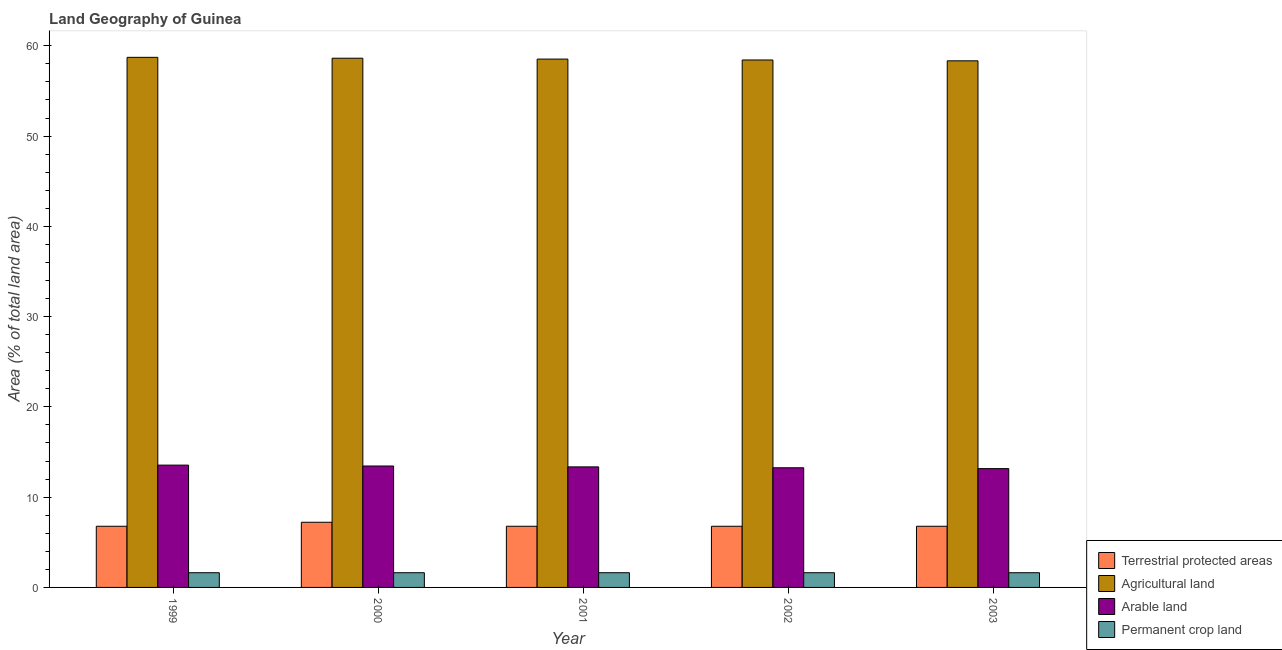How many different coloured bars are there?
Offer a very short reply. 4. How many groups of bars are there?
Your answer should be compact. 5. Are the number of bars per tick equal to the number of legend labels?
Your response must be concise. Yes. What is the percentage of land under terrestrial protection in 2002?
Keep it short and to the point. 6.78. Across all years, what is the maximum percentage of area under agricultural land?
Provide a short and direct response. 58.72. Across all years, what is the minimum percentage of area under arable land?
Your answer should be very brief. 13.16. What is the total percentage of land under terrestrial protection in the graph?
Keep it short and to the point. 34.32. What is the difference between the percentage of area under arable land in 2001 and that in 2002?
Ensure brevity in your answer.  0.1. What is the difference between the percentage of area under arable land in 2003 and the percentage of area under permanent crop land in 2002?
Your response must be concise. -0.09. What is the average percentage of land under terrestrial protection per year?
Offer a very short reply. 6.86. In the year 2000, what is the difference between the percentage of land under terrestrial protection and percentage of area under permanent crop land?
Offer a terse response. 0. In how many years, is the percentage of area under permanent crop land greater than 46 %?
Offer a terse response. 0. What is the ratio of the percentage of land under terrestrial protection in 1999 to that in 2002?
Provide a succinct answer. 1. Is the percentage of area under agricultural land in 1999 less than that in 2003?
Keep it short and to the point. No. Is the difference between the percentage of area under agricultural land in 1999 and 2002 greater than the difference between the percentage of area under arable land in 1999 and 2002?
Offer a very short reply. No. What is the difference between the highest and the second highest percentage of land under terrestrial protection?
Your answer should be very brief. 0.44. In how many years, is the percentage of area under agricultural land greater than the average percentage of area under agricultural land taken over all years?
Your answer should be very brief. 2. Is it the case that in every year, the sum of the percentage of area under arable land and percentage of area under permanent crop land is greater than the sum of percentage of area under agricultural land and percentage of land under terrestrial protection?
Ensure brevity in your answer.  No. What does the 1st bar from the left in 1999 represents?
Provide a short and direct response. Terrestrial protected areas. What does the 1st bar from the right in 2003 represents?
Ensure brevity in your answer.  Permanent crop land. Is it the case that in every year, the sum of the percentage of land under terrestrial protection and percentage of area under agricultural land is greater than the percentage of area under arable land?
Your answer should be compact. Yes. How many bars are there?
Keep it short and to the point. 20. What is the difference between two consecutive major ticks on the Y-axis?
Your response must be concise. 10. Are the values on the major ticks of Y-axis written in scientific E-notation?
Offer a very short reply. No. Does the graph contain any zero values?
Offer a terse response. No. Where does the legend appear in the graph?
Give a very brief answer. Bottom right. How many legend labels are there?
Ensure brevity in your answer.  4. How are the legend labels stacked?
Ensure brevity in your answer.  Vertical. What is the title of the graph?
Offer a very short reply. Land Geography of Guinea. Does "Secondary schools" appear as one of the legend labels in the graph?
Give a very brief answer. No. What is the label or title of the Y-axis?
Your answer should be compact. Area (% of total land area). What is the Area (% of total land area) in Terrestrial protected areas in 1999?
Keep it short and to the point. 6.78. What is the Area (% of total land area) of Agricultural land in 1999?
Your answer should be very brief. 58.72. What is the Area (% of total land area) of Arable land in 1999?
Your answer should be very brief. 13.55. What is the Area (% of total land area) of Permanent crop land in 1999?
Provide a short and direct response. 1.63. What is the Area (% of total land area) of Terrestrial protected areas in 2000?
Provide a succinct answer. 7.22. What is the Area (% of total land area) in Agricultural land in 2000?
Keep it short and to the point. 58.62. What is the Area (% of total land area) of Arable land in 2000?
Your response must be concise. 13.45. What is the Area (% of total land area) in Permanent crop land in 2000?
Make the answer very short. 1.63. What is the Area (% of total land area) in Terrestrial protected areas in 2001?
Your answer should be very brief. 6.78. What is the Area (% of total land area) in Agricultural land in 2001?
Your answer should be compact. 58.53. What is the Area (% of total land area) in Arable land in 2001?
Provide a succinct answer. 13.35. What is the Area (% of total land area) in Permanent crop land in 2001?
Keep it short and to the point. 1.63. What is the Area (% of total land area) of Terrestrial protected areas in 2002?
Offer a terse response. 6.78. What is the Area (% of total land area) of Agricultural land in 2002?
Your answer should be compact. 58.43. What is the Area (% of total land area) in Arable land in 2002?
Provide a short and direct response. 13.25. What is the Area (% of total land area) of Permanent crop land in 2002?
Offer a very short reply. 1.63. What is the Area (% of total land area) of Terrestrial protected areas in 2003?
Your answer should be compact. 6.78. What is the Area (% of total land area) in Agricultural land in 2003?
Provide a short and direct response. 58.33. What is the Area (% of total land area) in Arable land in 2003?
Your response must be concise. 13.16. What is the Area (% of total land area) of Permanent crop land in 2003?
Offer a terse response. 1.63. Across all years, what is the maximum Area (% of total land area) of Terrestrial protected areas?
Provide a succinct answer. 7.22. Across all years, what is the maximum Area (% of total land area) of Agricultural land?
Your answer should be very brief. 58.72. Across all years, what is the maximum Area (% of total land area) in Arable land?
Provide a short and direct response. 13.55. Across all years, what is the maximum Area (% of total land area) of Permanent crop land?
Provide a short and direct response. 1.63. Across all years, what is the minimum Area (% of total land area) of Terrestrial protected areas?
Your answer should be compact. 6.78. Across all years, what is the minimum Area (% of total land area) in Agricultural land?
Offer a very short reply. 58.33. Across all years, what is the minimum Area (% of total land area) in Arable land?
Ensure brevity in your answer.  13.16. Across all years, what is the minimum Area (% of total land area) in Permanent crop land?
Offer a very short reply. 1.63. What is the total Area (% of total land area) in Terrestrial protected areas in the graph?
Your answer should be compact. 34.32. What is the total Area (% of total land area) in Agricultural land in the graph?
Make the answer very short. 292.63. What is the total Area (% of total land area) in Arable land in the graph?
Ensure brevity in your answer.  66.77. What is the total Area (% of total land area) of Permanent crop land in the graph?
Your answer should be very brief. 8.14. What is the difference between the Area (% of total land area) in Terrestrial protected areas in 1999 and that in 2000?
Your answer should be compact. -0.44. What is the difference between the Area (% of total land area) in Agricultural land in 1999 and that in 2000?
Ensure brevity in your answer.  0.1. What is the difference between the Area (% of total land area) in Arable land in 1999 and that in 2000?
Offer a terse response. 0.1. What is the difference between the Area (% of total land area) of Permanent crop land in 1999 and that in 2000?
Make the answer very short. 0. What is the difference between the Area (% of total land area) in Agricultural land in 1999 and that in 2001?
Give a very brief answer. 0.2. What is the difference between the Area (% of total land area) in Arable land in 1999 and that in 2001?
Your answer should be compact. 0.2. What is the difference between the Area (% of total land area) of Permanent crop land in 1999 and that in 2001?
Your response must be concise. 0. What is the difference between the Area (% of total land area) in Agricultural land in 1999 and that in 2002?
Give a very brief answer. 0.29. What is the difference between the Area (% of total land area) of Arable land in 1999 and that in 2002?
Offer a very short reply. 0.29. What is the difference between the Area (% of total land area) in Terrestrial protected areas in 1999 and that in 2003?
Provide a short and direct response. -0. What is the difference between the Area (% of total land area) of Agricultural land in 1999 and that in 2003?
Ensure brevity in your answer.  0.39. What is the difference between the Area (% of total land area) in Arable land in 1999 and that in 2003?
Offer a terse response. 0.39. What is the difference between the Area (% of total land area) of Terrestrial protected areas in 2000 and that in 2001?
Make the answer very short. 0.44. What is the difference between the Area (% of total land area) of Agricultural land in 2000 and that in 2001?
Give a very brief answer. 0.1. What is the difference between the Area (% of total land area) in Arable land in 2000 and that in 2001?
Make the answer very short. 0.1. What is the difference between the Area (% of total land area) of Permanent crop land in 2000 and that in 2001?
Offer a very short reply. 0. What is the difference between the Area (% of total land area) in Terrestrial protected areas in 2000 and that in 2002?
Offer a very short reply. 0.44. What is the difference between the Area (% of total land area) of Agricultural land in 2000 and that in 2002?
Offer a very short reply. 0.2. What is the difference between the Area (% of total land area) of Arable land in 2000 and that in 2002?
Provide a short and direct response. 0.2. What is the difference between the Area (% of total land area) in Permanent crop land in 2000 and that in 2002?
Make the answer very short. 0. What is the difference between the Area (% of total land area) in Terrestrial protected areas in 2000 and that in 2003?
Your answer should be compact. 0.44. What is the difference between the Area (% of total land area) of Agricultural land in 2000 and that in 2003?
Offer a terse response. 0.29. What is the difference between the Area (% of total land area) of Arable land in 2000 and that in 2003?
Your response must be concise. 0.29. What is the difference between the Area (% of total land area) of Permanent crop land in 2000 and that in 2003?
Offer a very short reply. 0. What is the difference between the Area (% of total land area) in Terrestrial protected areas in 2001 and that in 2002?
Your response must be concise. 0. What is the difference between the Area (% of total land area) of Agricultural land in 2001 and that in 2002?
Ensure brevity in your answer.  0.1. What is the difference between the Area (% of total land area) in Arable land in 2001 and that in 2002?
Offer a terse response. 0.1. What is the difference between the Area (% of total land area) of Terrestrial protected areas in 2001 and that in 2003?
Offer a very short reply. -0. What is the difference between the Area (% of total land area) in Agricultural land in 2001 and that in 2003?
Keep it short and to the point. 0.19. What is the difference between the Area (% of total land area) in Arable land in 2001 and that in 2003?
Your answer should be compact. 0.19. What is the difference between the Area (% of total land area) in Terrestrial protected areas in 2002 and that in 2003?
Keep it short and to the point. -0. What is the difference between the Area (% of total land area) of Agricultural land in 2002 and that in 2003?
Ensure brevity in your answer.  0.09. What is the difference between the Area (% of total land area) of Arable land in 2002 and that in 2003?
Make the answer very short. 0.09. What is the difference between the Area (% of total land area) in Permanent crop land in 2002 and that in 2003?
Ensure brevity in your answer.  0. What is the difference between the Area (% of total land area) in Terrestrial protected areas in 1999 and the Area (% of total land area) in Agricultural land in 2000?
Give a very brief answer. -51.85. What is the difference between the Area (% of total land area) in Terrestrial protected areas in 1999 and the Area (% of total land area) in Arable land in 2000?
Give a very brief answer. -6.68. What is the difference between the Area (% of total land area) of Terrestrial protected areas in 1999 and the Area (% of total land area) of Permanent crop land in 2000?
Keep it short and to the point. 5.15. What is the difference between the Area (% of total land area) in Agricultural land in 1999 and the Area (% of total land area) in Arable land in 2000?
Keep it short and to the point. 45.27. What is the difference between the Area (% of total land area) of Agricultural land in 1999 and the Area (% of total land area) of Permanent crop land in 2000?
Ensure brevity in your answer.  57.09. What is the difference between the Area (% of total land area) of Arable land in 1999 and the Area (% of total land area) of Permanent crop land in 2000?
Provide a succinct answer. 11.92. What is the difference between the Area (% of total land area) of Terrestrial protected areas in 1999 and the Area (% of total land area) of Agricultural land in 2001?
Make the answer very short. -51.75. What is the difference between the Area (% of total land area) of Terrestrial protected areas in 1999 and the Area (% of total land area) of Arable land in 2001?
Give a very brief answer. -6.58. What is the difference between the Area (% of total land area) of Terrestrial protected areas in 1999 and the Area (% of total land area) of Permanent crop land in 2001?
Keep it short and to the point. 5.15. What is the difference between the Area (% of total land area) of Agricultural land in 1999 and the Area (% of total land area) of Arable land in 2001?
Keep it short and to the point. 45.37. What is the difference between the Area (% of total land area) in Agricultural land in 1999 and the Area (% of total land area) in Permanent crop land in 2001?
Offer a very short reply. 57.09. What is the difference between the Area (% of total land area) in Arable land in 1999 and the Area (% of total land area) in Permanent crop land in 2001?
Give a very brief answer. 11.92. What is the difference between the Area (% of total land area) of Terrestrial protected areas in 1999 and the Area (% of total land area) of Agricultural land in 2002?
Your answer should be very brief. -51.65. What is the difference between the Area (% of total land area) of Terrestrial protected areas in 1999 and the Area (% of total land area) of Arable land in 2002?
Keep it short and to the point. -6.48. What is the difference between the Area (% of total land area) in Terrestrial protected areas in 1999 and the Area (% of total land area) in Permanent crop land in 2002?
Keep it short and to the point. 5.15. What is the difference between the Area (% of total land area) in Agricultural land in 1999 and the Area (% of total land area) in Arable land in 2002?
Give a very brief answer. 45.47. What is the difference between the Area (% of total land area) of Agricultural land in 1999 and the Area (% of total land area) of Permanent crop land in 2002?
Your response must be concise. 57.09. What is the difference between the Area (% of total land area) in Arable land in 1999 and the Area (% of total land area) in Permanent crop land in 2002?
Your answer should be compact. 11.92. What is the difference between the Area (% of total land area) of Terrestrial protected areas in 1999 and the Area (% of total land area) of Agricultural land in 2003?
Make the answer very short. -51.56. What is the difference between the Area (% of total land area) of Terrestrial protected areas in 1999 and the Area (% of total land area) of Arable land in 2003?
Ensure brevity in your answer.  -6.39. What is the difference between the Area (% of total land area) in Terrestrial protected areas in 1999 and the Area (% of total land area) in Permanent crop land in 2003?
Offer a very short reply. 5.15. What is the difference between the Area (% of total land area) of Agricultural land in 1999 and the Area (% of total land area) of Arable land in 2003?
Provide a succinct answer. 45.56. What is the difference between the Area (% of total land area) in Agricultural land in 1999 and the Area (% of total land area) in Permanent crop land in 2003?
Provide a succinct answer. 57.09. What is the difference between the Area (% of total land area) in Arable land in 1999 and the Area (% of total land area) in Permanent crop land in 2003?
Offer a very short reply. 11.92. What is the difference between the Area (% of total land area) in Terrestrial protected areas in 2000 and the Area (% of total land area) in Agricultural land in 2001?
Make the answer very short. -51.31. What is the difference between the Area (% of total land area) in Terrestrial protected areas in 2000 and the Area (% of total land area) in Arable land in 2001?
Offer a terse response. -6.13. What is the difference between the Area (% of total land area) of Terrestrial protected areas in 2000 and the Area (% of total land area) of Permanent crop land in 2001?
Provide a succinct answer. 5.59. What is the difference between the Area (% of total land area) in Agricultural land in 2000 and the Area (% of total land area) in Arable land in 2001?
Give a very brief answer. 45.27. What is the difference between the Area (% of total land area) of Agricultural land in 2000 and the Area (% of total land area) of Permanent crop land in 2001?
Provide a succinct answer. 57. What is the difference between the Area (% of total land area) in Arable land in 2000 and the Area (% of total land area) in Permanent crop land in 2001?
Keep it short and to the point. 11.82. What is the difference between the Area (% of total land area) in Terrestrial protected areas in 2000 and the Area (% of total land area) in Agricultural land in 2002?
Provide a short and direct response. -51.21. What is the difference between the Area (% of total land area) of Terrestrial protected areas in 2000 and the Area (% of total land area) of Arable land in 2002?
Keep it short and to the point. -6.04. What is the difference between the Area (% of total land area) in Terrestrial protected areas in 2000 and the Area (% of total land area) in Permanent crop land in 2002?
Provide a succinct answer. 5.59. What is the difference between the Area (% of total land area) of Agricultural land in 2000 and the Area (% of total land area) of Arable land in 2002?
Make the answer very short. 45.37. What is the difference between the Area (% of total land area) in Agricultural land in 2000 and the Area (% of total land area) in Permanent crop land in 2002?
Offer a terse response. 57. What is the difference between the Area (% of total land area) of Arable land in 2000 and the Area (% of total land area) of Permanent crop land in 2002?
Offer a terse response. 11.82. What is the difference between the Area (% of total land area) in Terrestrial protected areas in 2000 and the Area (% of total land area) in Agricultural land in 2003?
Ensure brevity in your answer.  -51.12. What is the difference between the Area (% of total land area) of Terrestrial protected areas in 2000 and the Area (% of total land area) of Arable land in 2003?
Your answer should be very brief. -5.94. What is the difference between the Area (% of total land area) of Terrestrial protected areas in 2000 and the Area (% of total land area) of Permanent crop land in 2003?
Your answer should be very brief. 5.59. What is the difference between the Area (% of total land area) in Agricultural land in 2000 and the Area (% of total land area) in Arable land in 2003?
Your answer should be very brief. 45.46. What is the difference between the Area (% of total land area) in Agricultural land in 2000 and the Area (% of total land area) in Permanent crop land in 2003?
Give a very brief answer. 57. What is the difference between the Area (% of total land area) in Arable land in 2000 and the Area (% of total land area) in Permanent crop land in 2003?
Ensure brevity in your answer.  11.82. What is the difference between the Area (% of total land area) of Terrestrial protected areas in 2001 and the Area (% of total land area) of Agricultural land in 2002?
Your answer should be compact. -51.65. What is the difference between the Area (% of total land area) of Terrestrial protected areas in 2001 and the Area (% of total land area) of Arable land in 2002?
Keep it short and to the point. -6.48. What is the difference between the Area (% of total land area) in Terrestrial protected areas in 2001 and the Area (% of total land area) in Permanent crop land in 2002?
Offer a very short reply. 5.15. What is the difference between the Area (% of total land area) in Agricultural land in 2001 and the Area (% of total land area) in Arable land in 2002?
Make the answer very short. 45.27. What is the difference between the Area (% of total land area) in Agricultural land in 2001 and the Area (% of total land area) in Permanent crop land in 2002?
Your answer should be very brief. 56.9. What is the difference between the Area (% of total land area) in Arable land in 2001 and the Area (% of total land area) in Permanent crop land in 2002?
Make the answer very short. 11.72. What is the difference between the Area (% of total land area) of Terrestrial protected areas in 2001 and the Area (% of total land area) of Agricultural land in 2003?
Give a very brief answer. -51.56. What is the difference between the Area (% of total land area) of Terrestrial protected areas in 2001 and the Area (% of total land area) of Arable land in 2003?
Keep it short and to the point. -6.39. What is the difference between the Area (% of total land area) of Terrestrial protected areas in 2001 and the Area (% of total land area) of Permanent crop land in 2003?
Offer a very short reply. 5.15. What is the difference between the Area (% of total land area) of Agricultural land in 2001 and the Area (% of total land area) of Arable land in 2003?
Offer a terse response. 45.36. What is the difference between the Area (% of total land area) in Agricultural land in 2001 and the Area (% of total land area) in Permanent crop land in 2003?
Offer a terse response. 56.9. What is the difference between the Area (% of total land area) in Arable land in 2001 and the Area (% of total land area) in Permanent crop land in 2003?
Provide a succinct answer. 11.72. What is the difference between the Area (% of total land area) in Terrestrial protected areas in 2002 and the Area (% of total land area) in Agricultural land in 2003?
Your answer should be compact. -51.56. What is the difference between the Area (% of total land area) in Terrestrial protected areas in 2002 and the Area (% of total land area) in Arable land in 2003?
Offer a very short reply. -6.39. What is the difference between the Area (% of total land area) of Terrestrial protected areas in 2002 and the Area (% of total land area) of Permanent crop land in 2003?
Provide a short and direct response. 5.15. What is the difference between the Area (% of total land area) of Agricultural land in 2002 and the Area (% of total land area) of Arable land in 2003?
Your response must be concise. 45.27. What is the difference between the Area (% of total land area) of Agricultural land in 2002 and the Area (% of total land area) of Permanent crop land in 2003?
Your answer should be very brief. 56.8. What is the difference between the Area (% of total land area) in Arable land in 2002 and the Area (% of total land area) in Permanent crop land in 2003?
Keep it short and to the point. 11.63. What is the average Area (% of total land area) in Terrestrial protected areas per year?
Offer a very short reply. 6.86. What is the average Area (% of total land area) of Agricultural land per year?
Make the answer very short. 58.53. What is the average Area (% of total land area) in Arable land per year?
Your answer should be very brief. 13.35. What is the average Area (% of total land area) in Permanent crop land per year?
Offer a terse response. 1.63. In the year 1999, what is the difference between the Area (% of total land area) in Terrestrial protected areas and Area (% of total land area) in Agricultural land?
Your answer should be compact. -51.95. In the year 1999, what is the difference between the Area (% of total land area) in Terrestrial protected areas and Area (% of total land area) in Arable land?
Give a very brief answer. -6.77. In the year 1999, what is the difference between the Area (% of total land area) in Terrestrial protected areas and Area (% of total land area) in Permanent crop land?
Your answer should be very brief. 5.15. In the year 1999, what is the difference between the Area (% of total land area) of Agricultural land and Area (% of total land area) of Arable land?
Offer a terse response. 45.17. In the year 1999, what is the difference between the Area (% of total land area) in Agricultural land and Area (% of total land area) in Permanent crop land?
Make the answer very short. 57.09. In the year 1999, what is the difference between the Area (% of total land area) in Arable land and Area (% of total land area) in Permanent crop land?
Give a very brief answer. 11.92. In the year 2000, what is the difference between the Area (% of total land area) in Terrestrial protected areas and Area (% of total land area) in Agricultural land?
Your answer should be very brief. -51.4. In the year 2000, what is the difference between the Area (% of total land area) in Terrestrial protected areas and Area (% of total land area) in Arable land?
Offer a very short reply. -6.23. In the year 2000, what is the difference between the Area (% of total land area) of Terrestrial protected areas and Area (% of total land area) of Permanent crop land?
Make the answer very short. 5.59. In the year 2000, what is the difference between the Area (% of total land area) in Agricultural land and Area (% of total land area) in Arable land?
Give a very brief answer. 45.17. In the year 2000, what is the difference between the Area (% of total land area) of Agricultural land and Area (% of total land area) of Permanent crop land?
Give a very brief answer. 57. In the year 2000, what is the difference between the Area (% of total land area) of Arable land and Area (% of total land area) of Permanent crop land?
Keep it short and to the point. 11.82. In the year 2001, what is the difference between the Area (% of total land area) in Terrestrial protected areas and Area (% of total land area) in Agricultural land?
Give a very brief answer. -51.75. In the year 2001, what is the difference between the Area (% of total land area) in Terrestrial protected areas and Area (% of total land area) in Arable land?
Provide a succinct answer. -6.58. In the year 2001, what is the difference between the Area (% of total land area) in Terrestrial protected areas and Area (% of total land area) in Permanent crop land?
Make the answer very short. 5.15. In the year 2001, what is the difference between the Area (% of total land area) in Agricultural land and Area (% of total land area) in Arable land?
Provide a short and direct response. 45.17. In the year 2001, what is the difference between the Area (% of total land area) of Agricultural land and Area (% of total land area) of Permanent crop land?
Offer a terse response. 56.9. In the year 2001, what is the difference between the Area (% of total land area) of Arable land and Area (% of total land area) of Permanent crop land?
Provide a short and direct response. 11.72. In the year 2002, what is the difference between the Area (% of total land area) of Terrestrial protected areas and Area (% of total land area) of Agricultural land?
Your answer should be very brief. -51.65. In the year 2002, what is the difference between the Area (% of total land area) of Terrestrial protected areas and Area (% of total land area) of Arable land?
Provide a short and direct response. -6.48. In the year 2002, what is the difference between the Area (% of total land area) in Terrestrial protected areas and Area (% of total land area) in Permanent crop land?
Give a very brief answer. 5.15. In the year 2002, what is the difference between the Area (% of total land area) of Agricultural land and Area (% of total land area) of Arable land?
Keep it short and to the point. 45.17. In the year 2002, what is the difference between the Area (% of total land area) of Agricultural land and Area (% of total land area) of Permanent crop land?
Keep it short and to the point. 56.8. In the year 2002, what is the difference between the Area (% of total land area) in Arable land and Area (% of total land area) in Permanent crop land?
Your response must be concise. 11.63. In the year 2003, what is the difference between the Area (% of total land area) in Terrestrial protected areas and Area (% of total land area) in Agricultural land?
Give a very brief answer. -51.56. In the year 2003, what is the difference between the Area (% of total land area) in Terrestrial protected areas and Area (% of total land area) in Arable land?
Provide a short and direct response. -6.39. In the year 2003, what is the difference between the Area (% of total land area) in Terrestrial protected areas and Area (% of total land area) in Permanent crop land?
Your answer should be very brief. 5.15. In the year 2003, what is the difference between the Area (% of total land area) of Agricultural land and Area (% of total land area) of Arable land?
Make the answer very short. 45.17. In the year 2003, what is the difference between the Area (% of total land area) of Agricultural land and Area (% of total land area) of Permanent crop land?
Offer a very short reply. 56.71. In the year 2003, what is the difference between the Area (% of total land area) in Arable land and Area (% of total land area) in Permanent crop land?
Make the answer very short. 11.53. What is the ratio of the Area (% of total land area) in Terrestrial protected areas in 1999 to that in 2000?
Make the answer very short. 0.94. What is the ratio of the Area (% of total land area) in Arable land in 1999 to that in 2000?
Your answer should be very brief. 1.01. What is the ratio of the Area (% of total land area) in Agricultural land in 1999 to that in 2001?
Provide a short and direct response. 1. What is the ratio of the Area (% of total land area) in Arable land in 1999 to that in 2001?
Keep it short and to the point. 1.01. What is the ratio of the Area (% of total land area) of Permanent crop land in 1999 to that in 2001?
Make the answer very short. 1. What is the ratio of the Area (% of total land area) in Terrestrial protected areas in 1999 to that in 2002?
Offer a terse response. 1. What is the ratio of the Area (% of total land area) in Arable land in 1999 to that in 2002?
Your answer should be compact. 1.02. What is the ratio of the Area (% of total land area) in Terrestrial protected areas in 1999 to that in 2003?
Your answer should be compact. 1. What is the ratio of the Area (% of total land area) in Agricultural land in 1999 to that in 2003?
Provide a succinct answer. 1.01. What is the ratio of the Area (% of total land area) of Arable land in 1999 to that in 2003?
Your answer should be compact. 1.03. What is the ratio of the Area (% of total land area) of Terrestrial protected areas in 2000 to that in 2001?
Provide a succinct answer. 1.07. What is the ratio of the Area (% of total land area) of Arable land in 2000 to that in 2001?
Keep it short and to the point. 1.01. What is the ratio of the Area (% of total land area) in Terrestrial protected areas in 2000 to that in 2002?
Offer a very short reply. 1.07. What is the ratio of the Area (% of total land area) of Arable land in 2000 to that in 2002?
Ensure brevity in your answer.  1.01. What is the ratio of the Area (% of total land area) in Terrestrial protected areas in 2000 to that in 2003?
Your answer should be very brief. 1.07. What is the ratio of the Area (% of total land area) of Arable land in 2000 to that in 2003?
Offer a terse response. 1.02. What is the ratio of the Area (% of total land area) of Agricultural land in 2001 to that in 2002?
Your response must be concise. 1. What is the ratio of the Area (% of total land area) of Arable land in 2001 to that in 2002?
Your answer should be very brief. 1.01. What is the ratio of the Area (% of total land area) in Agricultural land in 2001 to that in 2003?
Your response must be concise. 1. What is the ratio of the Area (% of total land area) of Arable land in 2001 to that in 2003?
Give a very brief answer. 1.01. What is the ratio of the Area (% of total land area) in Permanent crop land in 2001 to that in 2003?
Provide a succinct answer. 1. What is the ratio of the Area (% of total land area) in Arable land in 2002 to that in 2003?
Ensure brevity in your answer.  1.01. What is the difference between the highest and the second highest Area (% of total land area) of Terrestrial protected areas?
Keep it short and to the point. 0.44. What is the difference between the highest and the second highest Area (% of total land area) in Agricultural land?
Your answer should be very brief. 0.1. What is the difference between the highest and the second highest Area (% of total land area) of Arable land?
Provide a short and direct response. 0.1. What is the difference between the highest and the lowest Area (% of total land area) of Terrestrial protected areas?
Provide a short and direct response. 0.44. What is the difference between the highest and the lowest Area (% of total land area) in Agricultural land?
Ensure brevity in your answer.  0.39. What is the difference between the highest and the lowest Area (% of total land area) in Arable land?
Ensure brevity in your answer.  0.39. What is the difference between the highest and the lowest Area (% of total land area) in Permanent crop land?
Your response must be concise. 0. 